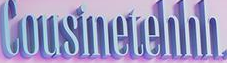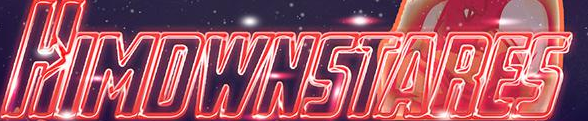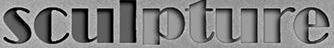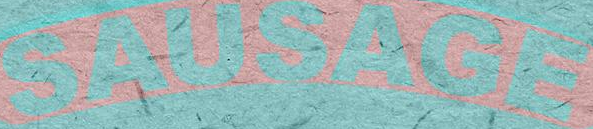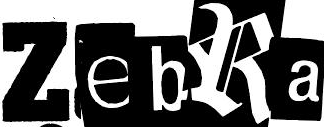What text is displayed in these images sequentially, separated by a semicolon? Cousinetehhh; HIMDWNSTARES; sculpture; SAUSAGE; ZebRa 